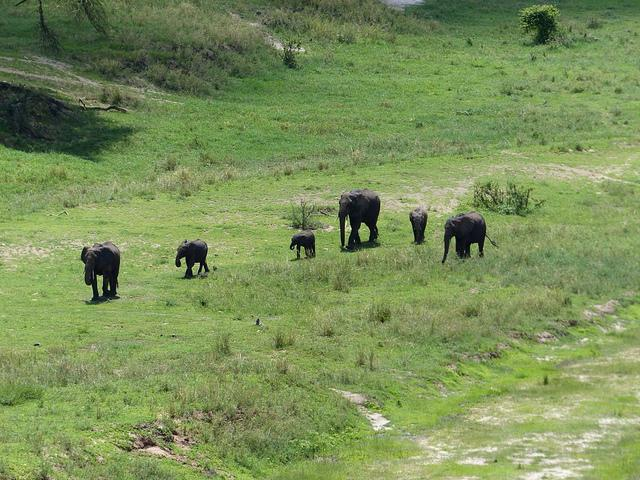Why might some of their trunks be curled? eating 